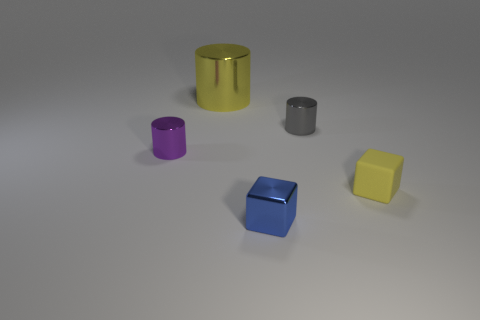Subtract all small shiny cylinders. How many cylinders are left? 1 Add 3 small blue shiny blocks. How many objects exist? 8 Subtract all brown cylinders. Subtract all brown cubes. How many cylinders are left? 3 Subtract 0 blue cylinders. How many objects are left? 5 Subtract all blocks. How many objects are left? 3 Subtract all big brown matte cylinders. Subtract all purple metallic things. How many objects are left? 4 Add 1 tiny purple metallic cylinders. How many tiny purple metallic cylinders are left? 2 Add 5 large metal cylinders. How many large metal cylinders exist? 6 